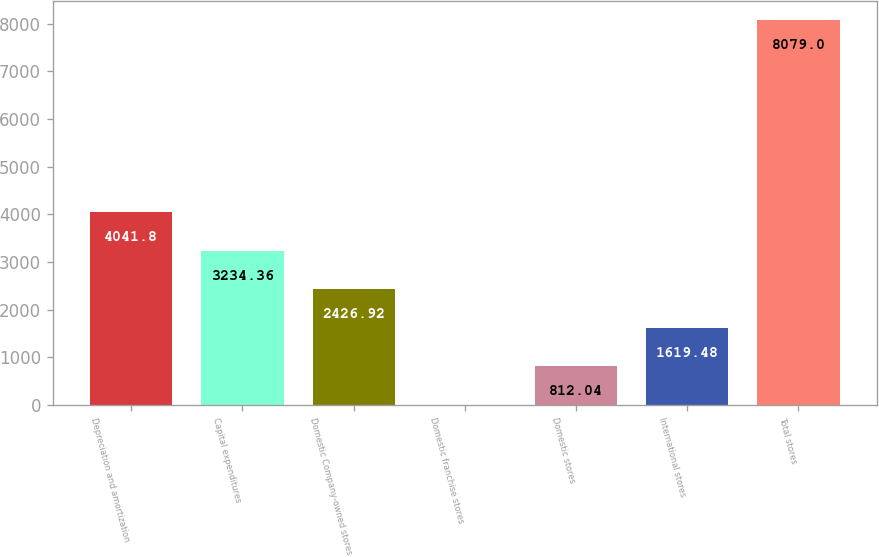Convert chart to OTSL. <chart><loc_0><loc_0><loc_500><loc_500><bar_chart><fcel>Depreciation and amortization<fcel>Capital expenditures<fcel>Domestic Company-owned stores<fcel>Domestic franchise stores<fcel>Domestic stores<fcel>International stores<fcel>Total stores<nl><fcel>4041.8<fcel>3234.36<fcel>2426.92<fcel>4.6<fcel>812.04<fcel>1619.48<fcel>8079<nl></chart> 